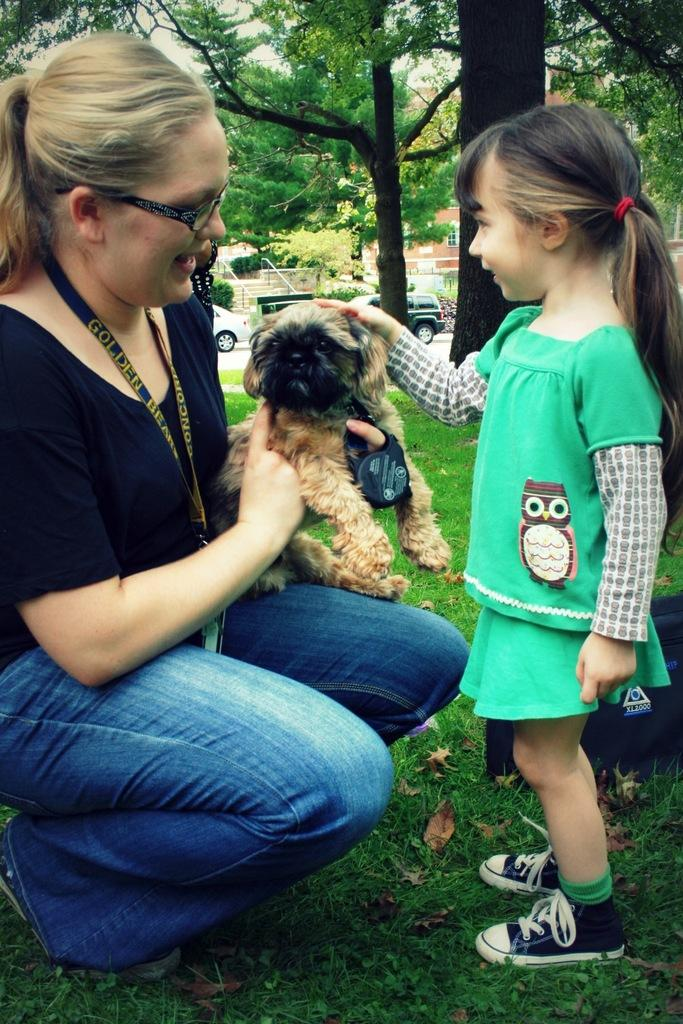How many people are in the image? There are two persons in the image. Where is the kid located in the image? The kid is on the right side of the image. Who is on the left side of the image? A woman is on the left side of the image. What is the woman holding in the image? The woman is holding a dog. What type of vegetation is visible in the background of the image? There are trees in the background of the image. What is the ground made of in the image? There is grass in the bottom of the image. What type of scissors can be seen in the image? There are no scissors present in the image. What is the marble's color in the image? There is no marble present in the image. 